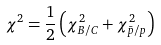Convert formula to latex. <formula><loc_0><loc_0><loc_500><loc_500>\chi ^ { 2 } = \frac { 1 } { 2 } \left ( \chi ^ { 2 } _ { B / C } + \chi ^ { 2 } _ { \bar { p } / p } \right ) \,</formula> 